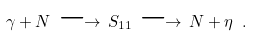<formula> <loc_0><loc_0><loc_500><loc_500>\gamma + N \, \longrightarrow \, S _ { 1 1 } \, \longrightarrow \, N + \eta \ .</formula> 